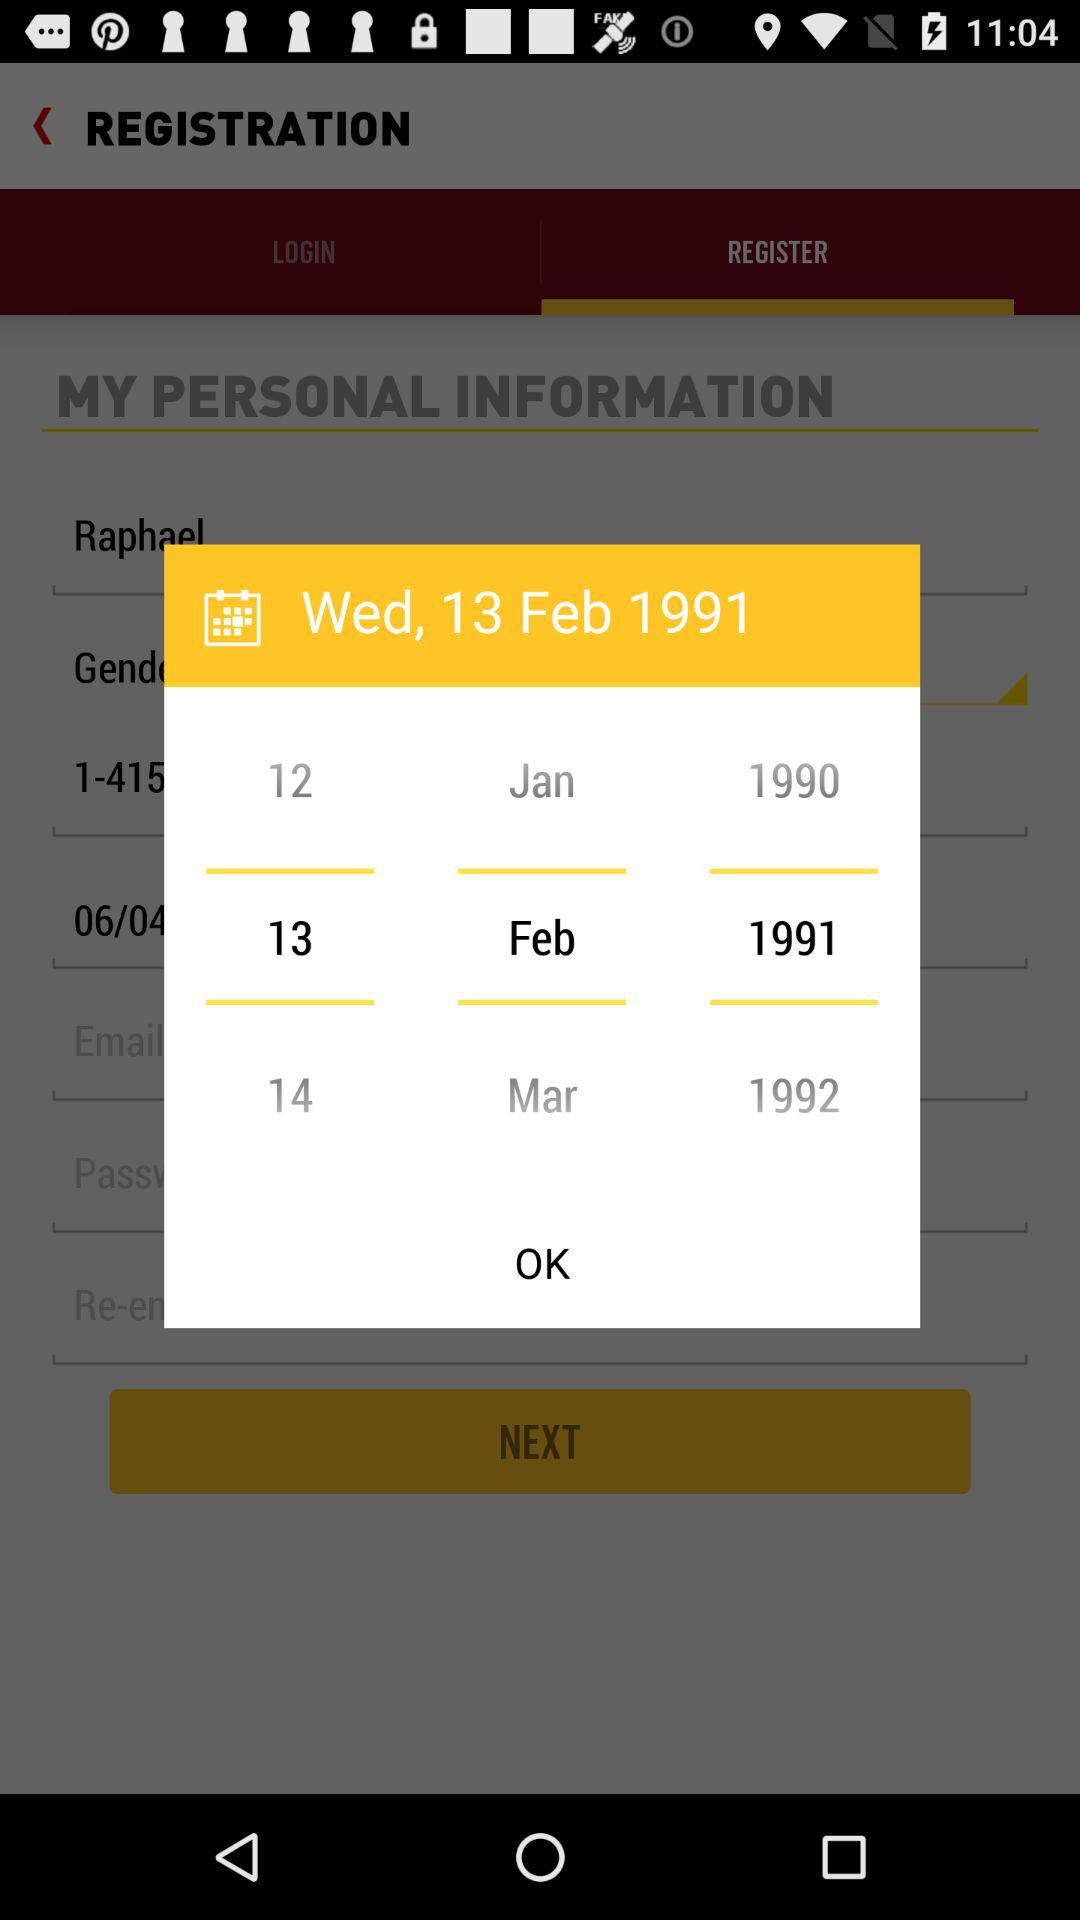What is the significance of the date displayed on the calendar? The date Wednesday, 13 Feb 1991 is highlighted, which might indicate it's been set as the user's birthdate in the registration form on the screen. 